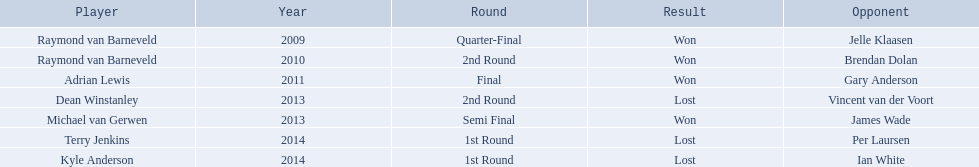Who were the contenders in the pdc world darts championship? Raymond van Barneveld, Raymond van Barneveld, Adrian Lewis, Dean Winstanley, Michael van Gerwen, Terry Jenkins, Kyle Anderson. Out of them, who didn't win? Dean Winstanley, Terry Jenkins, Kyle Anderson. Which of these contenders were beaten in 2014? Terry Jenkins, Kyle Anderson. Who are the other contenders apart from kyle anderson? Terry Jenkins. 